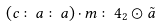<formula> <loc_0><loc_0><loc_500><loc_500>( c \colon a \colon a ) \cdot m \colon 4 _ { 2 } \odot \tilde { a }</formula> 